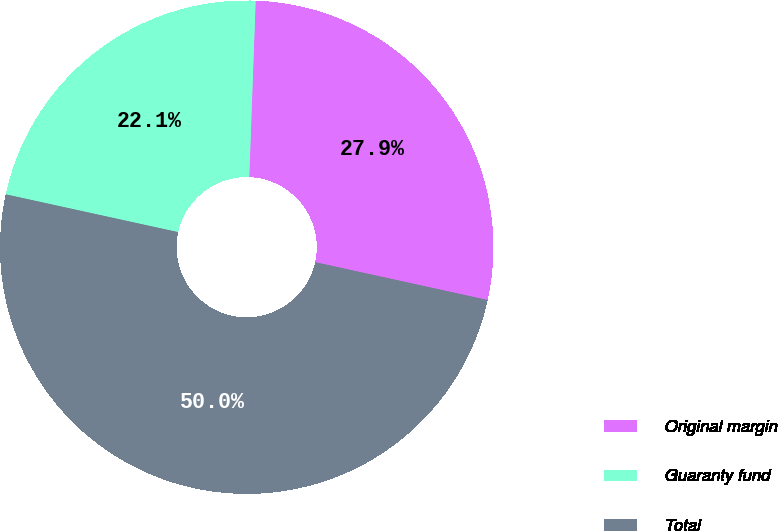<chart> <loc_0><loc_0><loc_500><loc_500><pie_chart><fcel>Original margin<fcel>Guaranty fund<fcel>Total<nl><fcel>27.86%<fcel>22.14%<fcel>50.0%<nl></chart> 